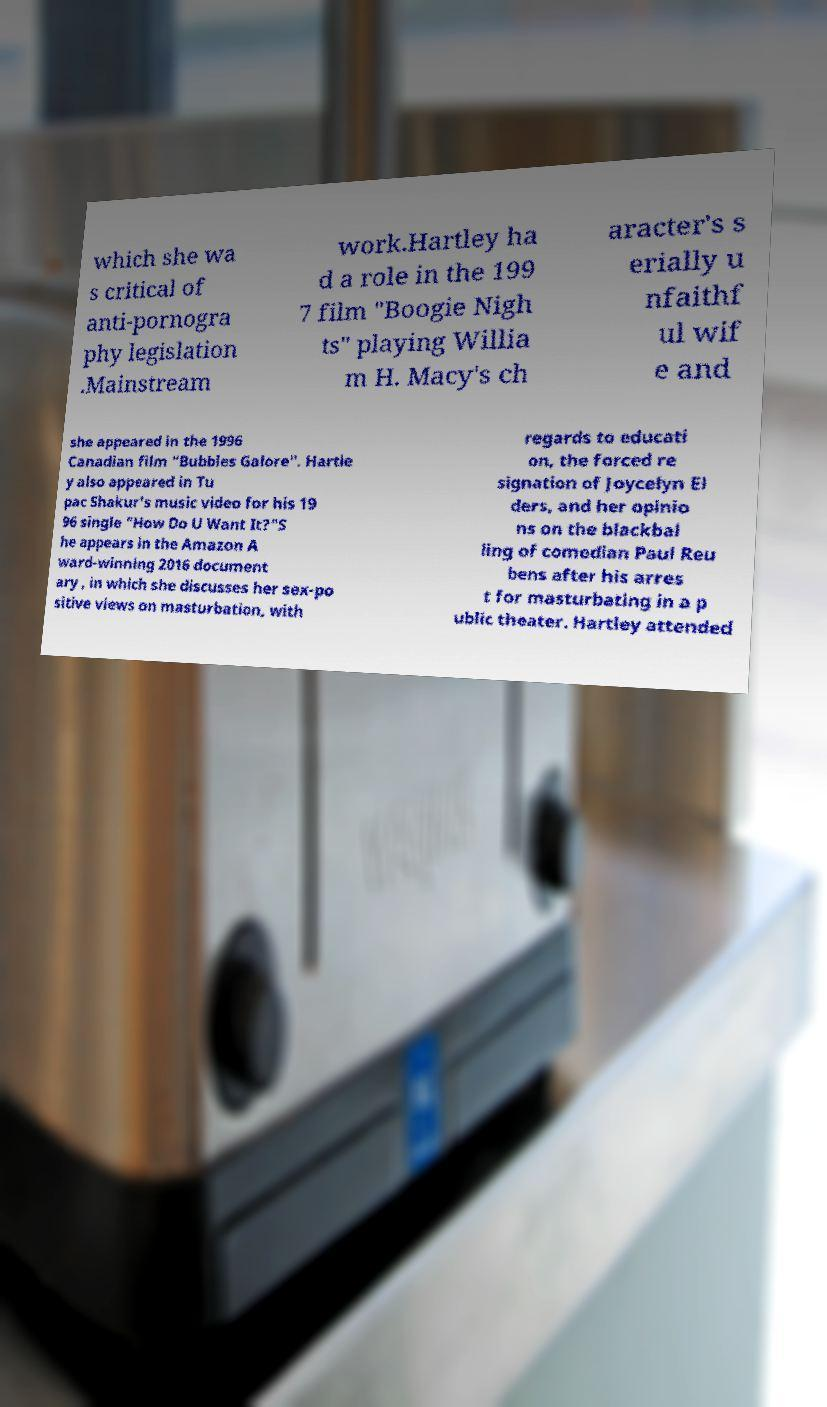Can you accurately transcribe the text from the provided image for me? which she wa s critical of anti-pornogra phy legislation .Mainstream work.Hartley ha d a role in the 199 7 film "Boogie Nigh ts" playing Willia m H. Macy's ch aracter's s erially u nfaithf ul wif e and she appeared in the 1996 Canadian film "Bubbles Galore". Hartle y also appeared in Tu pac Shakur's music video for his 19 96 single "How Do U Want It?"S he appears in the Amazon A ward-winning 2016 document ary , in which she discusses her sex-po sitive views on masturbation, with regards to educati on, the forced re signation of Joycelyn El ders, and her opinio ns on the blackbal ling of comedian Paul Reu bens after his arres t for masturbating in a p ublic theater. Hartley attended 